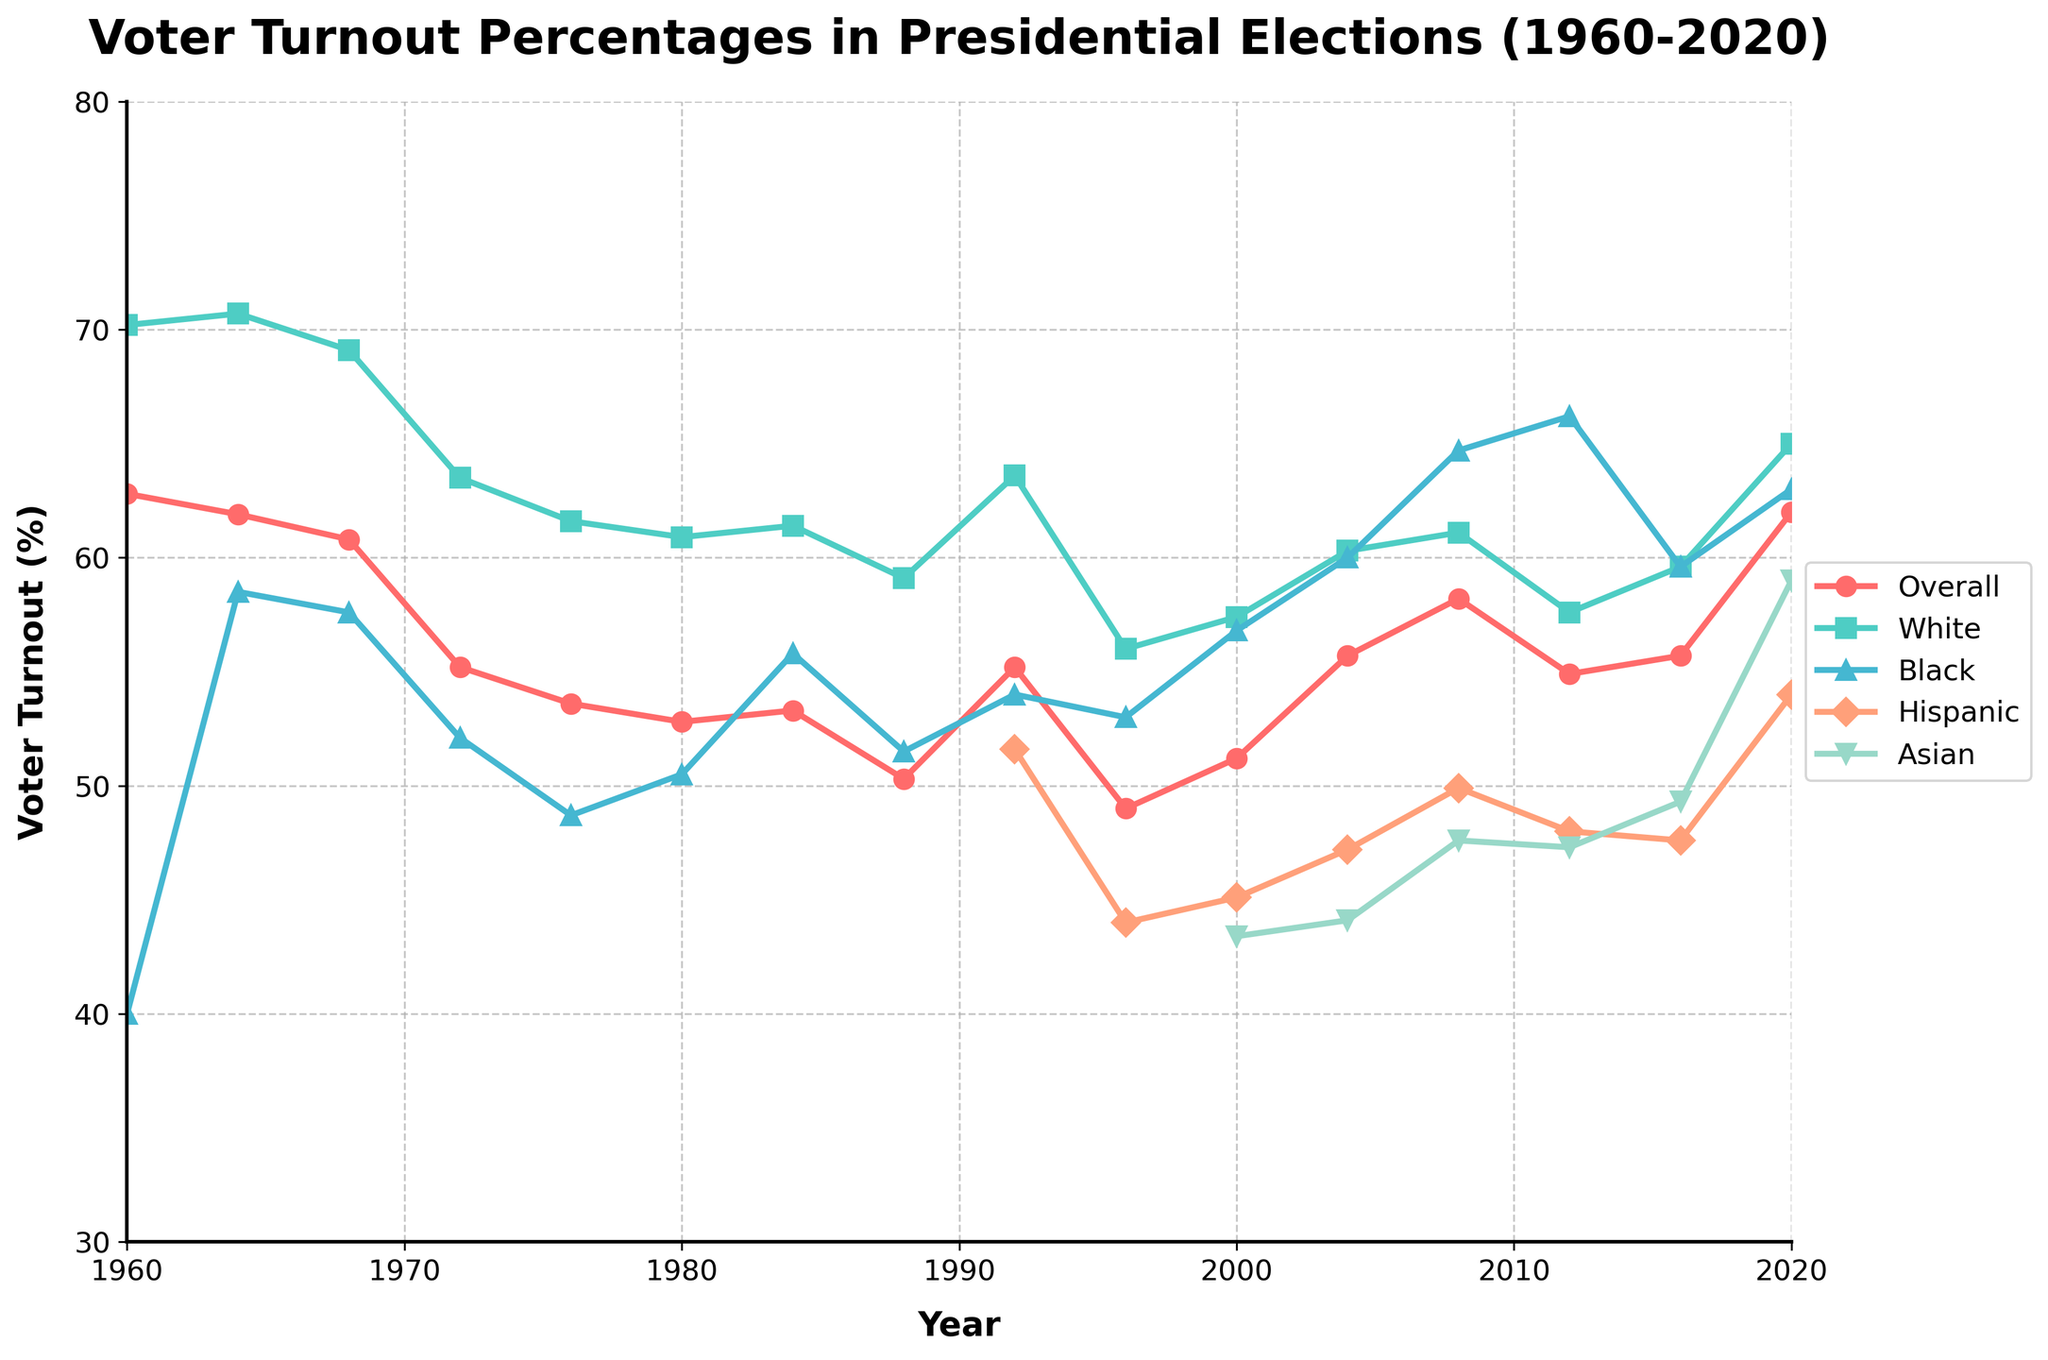What is the overall voter turnout percentage in the 2020 presidential election? Refer to the data on the chart for 2020 under the 'Overall' category.
Answer: 62.0% Between 1960 and 2020, in which year did Black voter turnout peak, and what was the percentage? Look for the highest point on the Black voter turnout line and its corresponding year and percentage.
Answer: 2012, 66.2% How did the voter turnout for Hispanics change from 1992 to 2020? Compare the percentage values for Hispanics in the years 1992 (51.6%) and 2020 (54.0%).
Answer: It increased by 2.4% Which age group had a voter turnout of more than 60% in 2020? Look at the lines corresponding to different age groups and check which exceed 60% in 2020.
Answer: 18-29, 30-44, 45-64, 65+ What is the difference in voter turnout between Whites and Blacks in 1988? Check the voter turnout percentages for Whites (59.1%) and Blacks (51.5%) in 1988 and calculate the difference.
Answer: 7.6% In which year did the overall voter turnout percentage drop below 50% for the first and only time? Look for the overall voter turnout line and find the year where it first drops below 50%.
Answer: 1996 Which demographic category showed the most significant increase in voter turnout between 2016 and 2020? Compare turnout percentages for all demographic categories in 2016 and 2020, calculate the differences, and find the largest.
Answer: Hispanic (6.4%) How does the voter turnout percentage for Asians in 2020 compare to Hispanics in the same year? Look at the voter turnout percentages for Asians (59.0%) and Hispanics (54.0%) in 2020 and compare them.
Answer: Asian turnout is 5% higher Calculate the average voter turnout percentage for the overall category from 1984 to 2000. Sum the voter turnout percentages from 1984 (53.3%), 1988 (50.3%), 1992 (55.2%), 1996 (49.0%), and 2000 (51.2%) and divide by 5.
Answer: 51.8% Which age group experienced the highest voter turnout in 2020? Look at the voter turnout percentages for each age group in 2020 and find the highest value.
Answer: 65+ 